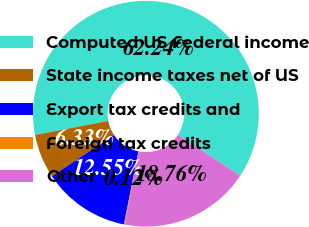Convert chart to OTSL. <chart><loc_0><loc_0><loc_500><loc_500><pie_chart><fcel>Computed US Federal income<fcel>State income taxes net of US<fcel>Export tax credits and<fcel>Foreign tax credits<fcel>Other<nl><fcel>62.24%<fcel>6.33%<fcel>12.55%<fcel>0.12%<fcel>18.76%<nl></chart> 